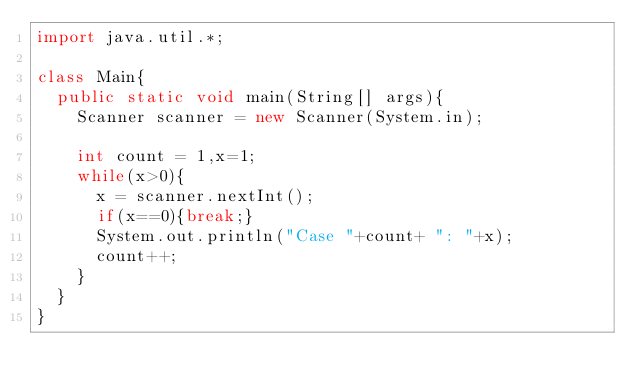Convert code to text. <code><loc_0><loc_0><loc_500><loc_500><_Java_>import java.util.*;

class Main{
	public static void main(String[] args){
		Scanner scanner = new Scanner(System.in);

		int count = 1,x=1;
		while(x>0){
			x = scanner.nextInt();
			if(x==0){break;}
			System.out.println("Case "+count+ ": "+x);
			count++;
		}
	}
}</code> 